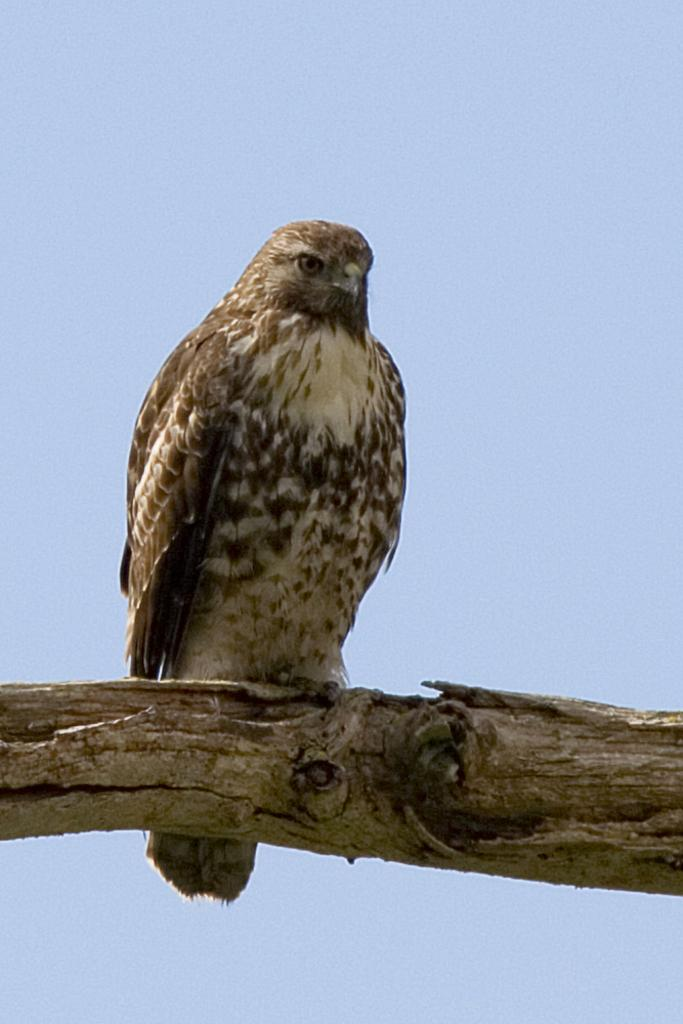What animal is present in the image? There is an eagle in the image. Where is the eagle located in the image? The eagle is on a tree branch. What color is the sky in the image? The sky is blue in the image. How does the man feel about the deer in the image? There is no man or deer present in the image; it features an eagle on a tree branch with a blue sky. 